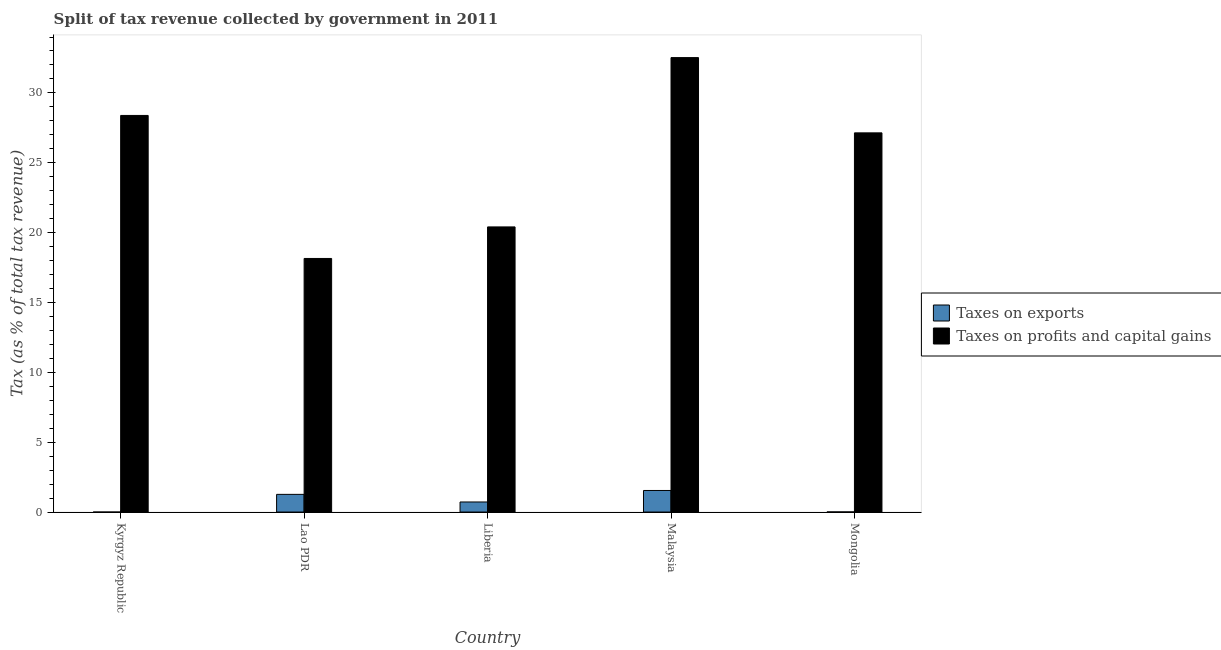How many different coloured bars are there?
Your answer should be very brief. 2. Are the number of bars on each tick of the X-axis equal?
Your answer should be compact. No. What is the label of the 4th group of bars from the left?
Ensure brevity in your answer.  Malaysia. What is the percentage of revenue obtained from taxes on exports in Mongolia?
Offer a terse response. 0.01. Across all countries, what is the maximum percentage of revenue obtained from taxes on profits and capital gains?
Your answer should be compact. 32.53. Across all countries, what is the minimum percentage of revenue obtained from taxes on profits and capital gains?
Give a very brief answer. 18.15. In which country was the percentage of revenue obtained from taxes on exports maximum?
Give a very brief answer. Malaysia. What is the total percentage of revenue obtained from taxes on exports in the graph?
Offer a terse response. 3.54. What is the difference between the percentage of revenue obtained from taxes on exports in Liberia and that in Mongolia?
Your response must be concise. 0.71. What is the difference between the percentage of revenue obtained from taxes on profits and capital gains in Kyrgyz Republic and the percentage of revenue obtained from taxes on exports in Mongolia?
Offer a terse response. 28.38. What is the average percentage of revenue obtained from taxes on profits and capital gains per country?
Offer a terse response. 25.32. What is the difference between the percentage of revenue obtained from taxes on exports and percentage of revenue obtained from taxes on profits and capital gains in Mongolia?
Make the answer very short. -27.13. What is the ratio of the percentage of revenue obtained from taxes on exports in Liberia to that in Malaysia?
Your answer should be compact. 0.47. What is the difference between the highest and the second highest percentage of revenue obtained from taxes on exports?
Your answer should be compact. 0.28. What is the difference between the highest and the lowest percentage of revenue obtained from taxes on exports?
Make the answer very short. 1.54. Does the graph contain any zero values?
Provide a short and direct response. Yes. Does the graph contain grids?
Offer a terse response. No. Where does the legend appear in the graph?
Your answer should be compact. Center right. How are the legend labels stacked?
Ensure brevity in your answer.  Vertical. What is the title of the graph?
Make the answer very short. Split of tax revenue collected by government in 2011. What is the label or title of the Y-axis?
Provide a succinct answer. Tax (as % of total tax revenue). What is the Tax (as % of total tax revenue) of Taxes on exports in Kyrgyz Republic?
Provide a short and direct response. 0. What is the Tax (as % of total tax revenue) in Taxes on profits and capital gains in Kyrgyz Republic?
Ensure brevity in your answer.  28.39. What is the Tax (as % of total tax revenue) in Taxes on exports in Lao PDR?
Ensure brevity in your answer.  1.26. What is the Tax (as % of total tax revenue) in Taxes on profits and capital gains in Lao PDR?
Keep it short and to the point. 18.15. What is the Tax (as % of total tax revenue) in Taxes on exports in Liberia?
Keep it short and to the point. 0.72. What is the Tax (as % of total tax revenue) of Taxes on profits and capital gains in Liberia?
Your response must be concise. 20.41. What is the Tax (as % of total tax revenue) in Taxes on exports in Malaysia?
Make the answer very short. 1.54. What is the Tax (as % of total tax revenue) in Taxes on profits and capital gains in Malaysia?
Your answer should be compact. 32.53. What is the Tax (as % of total tax revenue) in Taxes on exports in Mongolia?
Provide a succinct answer. 0.01. What is the Tax (as % of total tax revenue) of Taxes on profits and capital gains in Mongolia?
Offer a very short reply. 27.14. Across all countries, what is the maximum Tax (as % of total tax revenue) of Taxes on exports?
Keep it short and to the point. 1.54. Across all countries, what is the maximum Tax (as % of total tax revenue) in Taxes on profits and capital gains?
Give a very brief answer. 32.53. Across all countries, what is the minimum Tax (as % of total tax revenue) of Taxes on profits and capital gains?
Give a very brief answer. 18.15. What is the total Tax (as % of total tax revenue) in Taxes on exports in the graph?
Give a very brief answer. 3.54. What is the total Tax (as % of total tax revenue) of Taxes on profits and capital gains in the graph?
Offer a very short reply. 126.61. What is the difference between the Tax (as % of total tax revenue) in Taxes on profits and capital gains in Kyrgyz Republic and that in Lao PDR?
Your answer should be compact. 10.24. What is the difference between the Tax (as % of total tax revenue) of Taxes on profits and capital gains in Kyrgyz Republic and that in Liberia?
Your response must be concise. 7.98. What is the difference between the Tax (as % of total tax revenue) in Taxes on profits and capital gains in Kyrgyz Republic and that in Malaysia?
Your answer should be compact. -4.14. What is the difference between the Tax (as % of total tax revenue) in Taxes on profits and capital gains in Kyrgyz Republic and that in Mongolia?
Offer a terse response. 1.25. What is the difference between the Tax (as % of total tax revenue) in Taxes on exports in Lao PDR and that in Liberia?
Keep it short and to the point. 0.54. What is the difference between the Tax (as % of total tax revenue) in Taxes on profits and capital gains in Lao PDR and that in Liberia?
Keep it short and to the point. -2.26. What is the difference between the Tax (as % of total tax revenue) in Taxes on exports in Lao PDR and that in Malaysia?
Provide a short and direct response. -0.28. What is the difference between the Tax (as % of total tax revenue) of Taxes on profits and capital gains in Lao PDR and that in Malaysia?
Provide a short and direct response. -14.38. What is the difference between the Tax (as % of total tax revenue) of Taxes on exports in Lao PDR and that in Mongolia?
Your answer should be very brief. 1.26. What is the difference between the Tax (as % of total tax revenue) in Taxes on profits and capital gains in Lao PDR and that in Mongolia?
Ensure brevity in your answer.  -8.99. What is the difference between the Tax (as % of total tax revenue) of Taxes on exports in Liberia and that in Malaysia?
Give a very brief answer. -0.82. What is the difference between the Tax (as % of total tax revenue) of Taxes on profits and capital gains in Liberia and that in Malaysia?
Provide a succinct answer. -12.12. What is the difference between the Tax (as % of total tax revenue) of Taxes on exports in Liberia and that in Mongolia?
Your response must be concise. 0.71. What is the difference between the Tax (as % of total tax revenue) of Taxes on profits and capital gains in Liberia and that in Mongolia?
Provide a short and direct response. -6.73. What is the difference between the Tax (as % of total tax revenue) in Taxes on exports in Malaysia and that in Mongolia?
Your response must be concise. 1.54. What is the difference between the Tax (as % of total tax revenue) of Taxes on profits and capital gains in Malaysia and that in Mongolia?
Offer a very short reply. 5.39. What is the difference between the Tax (as % of total tax revenue) in Taxes on exports in Lao PDR and the Tax (as % of total tax revenue) in Taxes on profits and capital gains in Liberia?
Ensure brevity in your answer.  -19.14. What is the difference between the Tax (as % of total tax revenue) in Taxes on exports in Lao PDR and the Tax (as % of total tax revenue) in Taxes on profits and capital gains in Malaysia?
Your response must be concise. -31.26. What is the difference between the Tax (as % of total tax revenue) in Taxes on exports in Lao PDR and the Tax (as % of total tax revenue) in Taxes on profits and capital gains in Mongolia?
Provide a short and direct response. -25.87. What is the difference between the Tax (as % of total tax revenue) of Taxes on exports in Liberia and the Tax (as % of total tax revenue) of Taxes on profits and capital gains in Malaysia?
Your response must be concise. -31.81. What is the difference between the Tax (as % of total tax revenue) of Taxes on exports in Liberia and the Tax (as % of total tax revenue) of Taxes on profits and capital gains in Mongolia?
Your answer should be compact. -26.42. What is the difference between the Tax (as % of total tax revenue) in Taxes on exports in Malaysia and the Tax (as % of total tax revenue) in Taxes on profits and capital gains in Mongolia?
Make the answer very short. -25.6. What is the average Tax (as % of total tax revenue) of Taxes on exports per country?
Offer a terse response. 0.71. What is the average Tax (as % of total tax revenue) of Taxes on profits and capital gains per country?
Your answer should be very brief. 25.32. What is the difference between the Tax (as % of total tax revenue) in Taxes on exports and Tax (as % of total tax revenue) in Taxes on profits and capital gains in Lao PDR?
Give a very brief answer. -16.89. What is the difference between the Tax (as % of total tax revenue) in Taxes on exports and Tax (as % of total tax revenue) in Taxes on profits and capital gains in Liberia?
Give a very brief answer. -19.69. What is the difference between the Tax (as % of total tax revenue) of Taxes on exports and Tax (as % of total tax revenue) of Taxes on profits and capital gains in Malaysia?
Offer a terse response. -30.98. What is the difference between the Tax (as % of total tax revenue) in Taxes on exports and Tax (as % of total tax revenue) in Taxes on profits and capital gains in Mongolia?
Keep it short and to the point. -27.13. What is the ratio of the Tax (as % of total tax revenue) of Taxes on profits and capital gains in Kyrgyz Republic to that in Lao PDR?
Your answer should be compact. 1.56. What is the ratio of the Tax (as % of total tax revenue) in Taxes on profits and capital gains in Kyrgyz Republic to that in Liberia?
Ensure brevity in your answer.  1.39. What is the ratio of the Tax (as % of total tax revenue) in Taxes on profits and capital gains in Kyrgyz Republic to that in Malaysia?
Your response must be concise. 0.87. What is the ratio of the Tax (as % of total tax revenue) of Taxes on profits and capital gains in Kyrgyz Republic to that in Mongolia?
Provide a short and direct response. 1.05. What is the ratio of the Tax (as % of total tax revenue) in Taxes on exports in Lao PDR to that in Liberia?
Provide a succinct answer. 1.76. What is the ratio of the Tax (as % of total tax revenue) in Taxes on profits and capital gains in Lao PDR to that in Liberia?
Ensure brevity in your answer.  0.89. What is the ratio of the Tax (as % of total tax revenue) in Taxes on exports in Lao PDR to that in Malaysia?
Your response must be concise. 0.82. What is the ratio of the Tax (as % of total tax revenue) of Taxes on profits and capital gains in Lao PDR to that in Malaysia?
Give a very brief answer. 0.56. What is the ratio of the Tax (as % of total tax revenue) of Taxes on exports in Lao PDR to that in Mongolia?
Give a very brief answer. 165.84. What is the ratio of the Tax (as % of total tax revenue) of Taxes on profits and capital gains in Lao PDR to that in Mongolia?
Your answer should be very brief. 0.67. What is the ratio of the Tax (as % of total tax revenue) in Taxes on exports in Liberia to that in Malaysia?
Ensure brevity in your answer.  0.47. What is the ratio of the Tax (as % of total tax revenue) of Taxes on profits and capital gains in Liberia to that in Malaysia?
Your response must be concise. 0.63. What is the ratio of the Tax (as % of total tax revenue) in Taxes on exports in Liberia to that in Mongolia?
Keep it short and to the point. 94.44. What is the ratio of the Tax (as % of total tax revenue) of Taxes on profits and capital gains in Liberia to that in Mongolia?
Give a very brief answer. 0.75. What is the ratio of the Tax (as % of total tax revenue) of Taxes on exports in Malaysia to that in Mongolia?
Your response must be concise. 202.34. What is the ratio of the Tax (as % of total tax revenue) of Taxes on profits and capital gains in Malaysia to that in Mongolia?
Make the answer very short. 1.2. What is the difference between the highest and the second highest Tax (as % of total tax revenue) in Taxes on exports?
Offer a very short reply. 0.28. What is the difference between the highest and the second highest Tax (as % of total tax revenue) in Taxes on profits and capital gains?
Provide a short and direct response. 4.14. What is the difference between the highest and the lowest Tax (as % of total tax revenue) of Taxes on exports?
Ensure brevity in your answer.  1.54. What is the difference between the highest and the lowest Tax (as % of total tax revenue) of Taxes on profits and capital gains?
Your response must be concise. 14.38. 